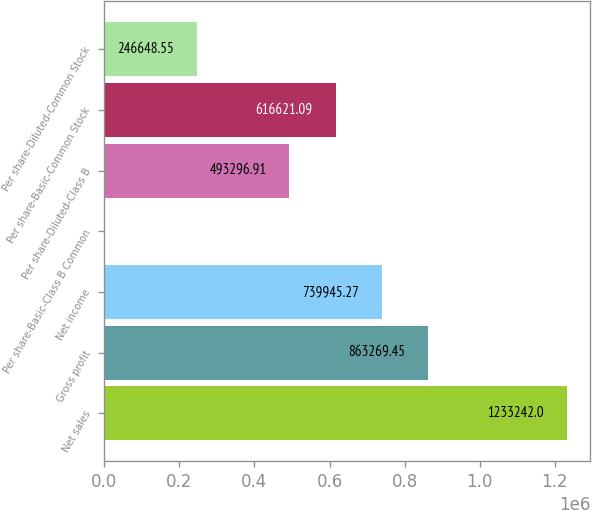Convert chart to OTSL. <chart><loc_0><loc_0><loc_500><loc_500><bar_chart><fcel>Net sales<fcel>Gross profit<fcel>Net income<fcel>Per share-Basic-Class B Common<fcel>Per share-Diluted-Class B<fcel>Per share-Basic-Common Stock<fcel>Per share-Diluted-Common Stock<nl><fcel>1.23324e+06<fcel>863269<fcel>739945<fcel>0.19<fcel>493297<fcel>616621<fcel>246649<nl></chart> 